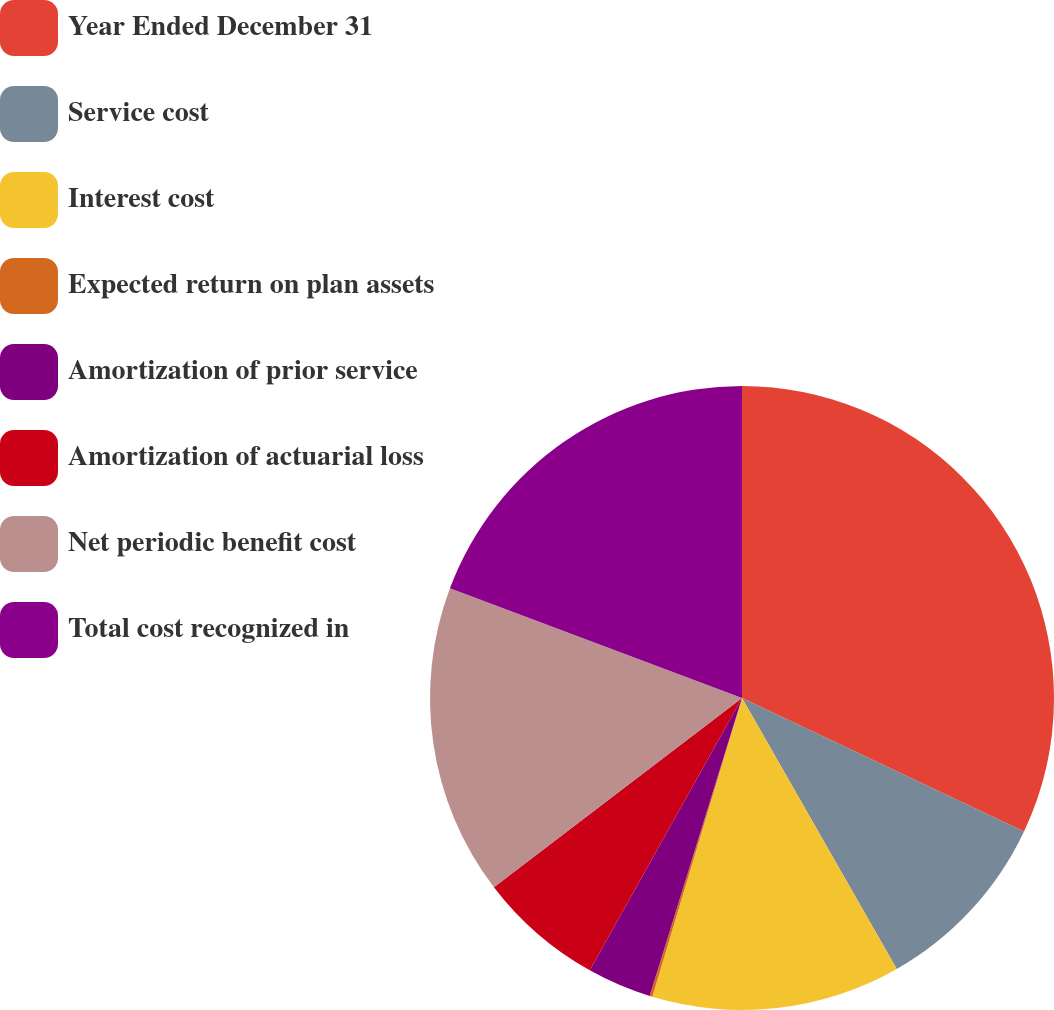Convert chart. <chart><loc_0><loc_0><loc_500><loc_500><pie_chart><fcel>Year Ended December 31<fcel>Service cost<fcel>Interest cost<fcel>Expected return on plan assets<fcel>Amortization of prior service<fcel>Amortization of actuarial loss<fcel>Net periodic benefit cost<fcel>Total cost recognized in<nl><fcel>32.03%<fcel>9.71%<fcel>12.9%<fcel>0.14%<fcel>3.33%<fcel>6.52%<fcel>16.09%<fcel>19.28%<nl></chart> 